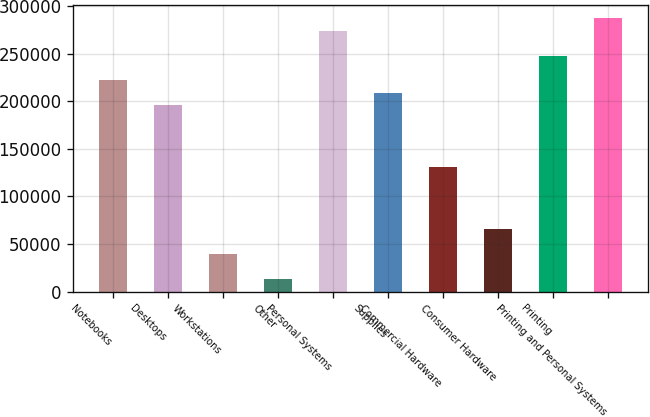<chart> <loc_0><loc_0><loc_500><loc_500><bar_chart><fcel>Notebooks<fcel>Desktops<fcel>Workstations<fcel>Other<fcel>Personal Systems<fcel>Supplies<fcel>Commercial Hardware<fcel>Consumer Hardware<fcel>Printing<fcel>Printing and Personal Systems<nl><fcel>222022<fcel>195926<fcel>39351.7<fcel>13255.9<fcel>274214<fcel>208974<fcel>130687<fcel>65447.5<fcel>248118<fcel>287262<nl></chart> 